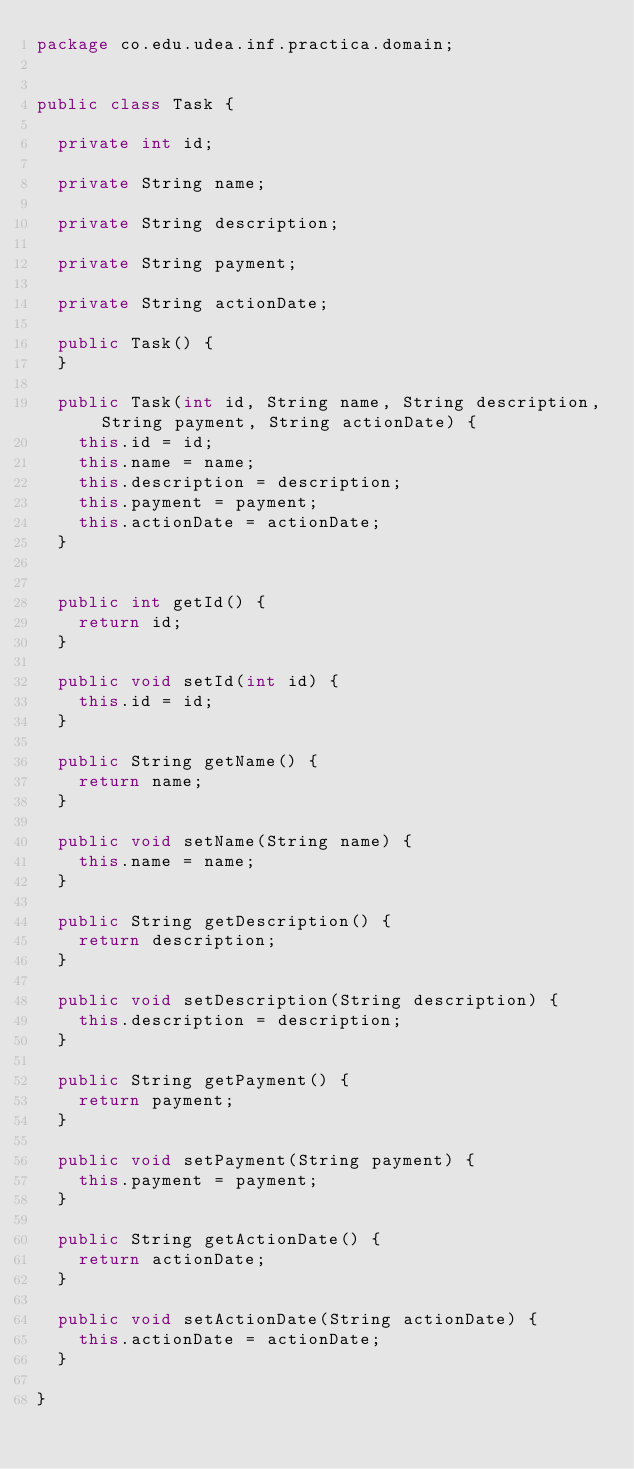<code> <loc_0><loc_0><loc_500><loc_500><_Java_>package co.edu.udea.inf.practica.domain;


public class Task {

	private int id;

	private String name;

	private String description;

	private String payment;

	private String actionDate;

	public Task() {
	}

	public Task(int id, String name, String description, String payment, String actionDate) {
		this.id = id;
		this.name = name;
		this.description = description;
		this.payment = payment;
		this.actionDate = actionDate;
	}


	public int getId() {
		return id;
	}

	public void setId(int id) {
		this.id = id;
	}

	public String getName() {
		return name;
	}

	public void setName(String name) {
		this.name = name;
	}

	public String getDescription() {
		return description;
	}

	public void setDescription(String description) {
		this.description = description;
	}

	public String getPayment() {
		return payment;
	}

	public void setPayment(String payment) {
		this.payment = payment;
	}

	public String getActionDate() {
		return actionDate;
	}

	public void setActionDate(String actionDate) {
		this.actionDate = actionDate;
	}

}
</code> 